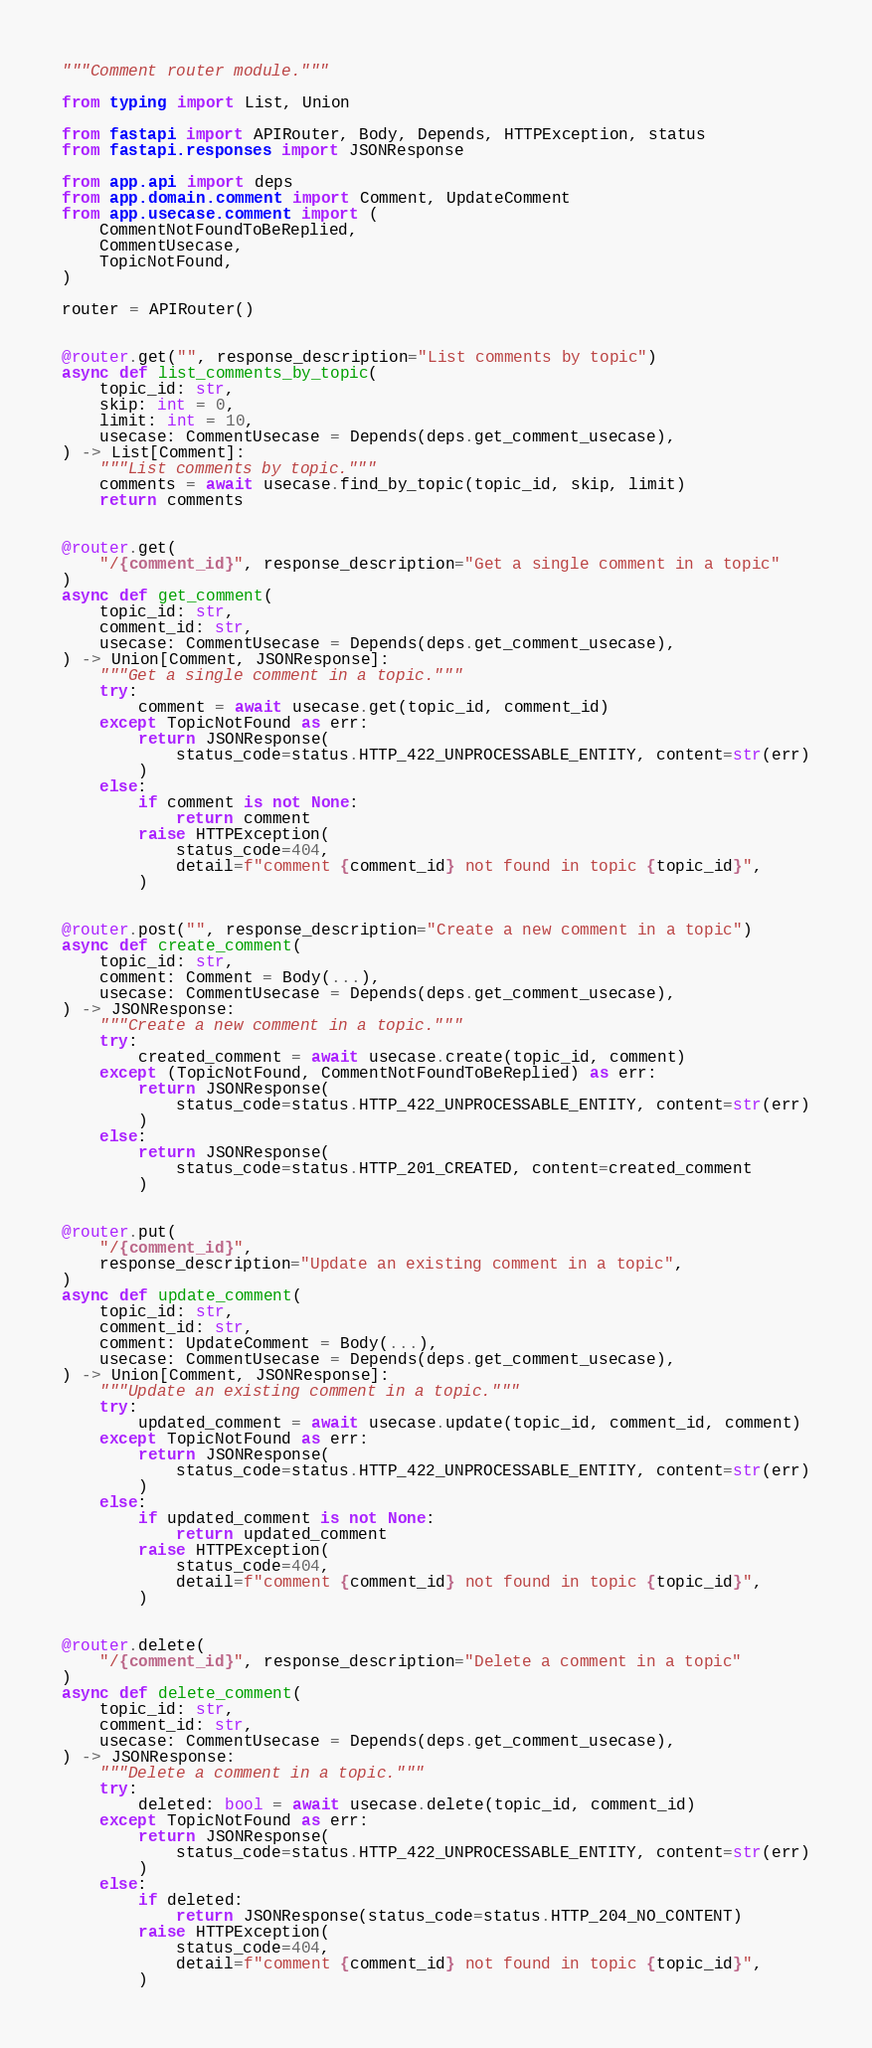<code> <loc_0><loc_0><loc_500><loc_500><_Python_>"""Comment router module."""

from typing import List, Union

from fastapi import APIRouter, Body, Depends, HTTPException, status
from fastapi.responses import JSONResponse

from app.api import deps
from app.domain.comment import Comment, UpdateComment
from app.usecase.comment import (
    CommentNotFoundToBeReplied,
    CommentUsecase,
    TopicNotFound,
)

router = APIRouter()


@router.get("", response_description="List comments by topic")
async def list_comments_by_topic(
    topic_id: str,
    skip: int = 0,
    limit: int = 10,
    usecase: CommentUsecase = Depends(deps.get_comment_usecase),
) -> List[Comment]:
    """List comments by topic."""
    comments = await usecase.find_by_topic(topic_id, skip, limit)
    return comments


@router.get(
    "/{comment_id}", response_description="Get a single comment in a topic"
)
async def get_comment(
    topic_id: str,
    comment_id: str,
    usecase: CommentUsecase = Depends(deps.get_comment_usecase),
) -> Union[Comment, JSONResponse]:
    """Get a single comment in a topic."""
    try:
        comment = await usecase.get(topic_id, comment_id)
    except TopicNotFound as err:
        return JSONResponse(
            status_code=status.HTTP_422_UNPROCESSABLE_ENTITY, content=str(err)
        )
    else:
        if comment is not None:
            return comment
        raise HTTPException(
            status_code=404,
            detail=f"comment {comment_id} not found in topic {topic_id}",
        )


@router.post("", response_description="Create a new comment in a topic")
async def create_comment(
    topic_id: str,
    comment: Comment = Body(...),
    usecase: CommentUsecase = Depends(deps.get_comment_usecase),
) -> JSONResponse:
    """Create a new comment in a topic."""
    try:
        created_comment = await usecase.create(topic_id, comment)
    except (TopicNotFound, CommentNotFoundToBeReplied) as err:
        return JSONResponse(
            status_code=status.HTTP_422_UNPROCESSABLE_ENTITY, content=str(err)
        )
    else:
        return JSONResponse(
            status_code=status.HTTP_201_CREATED, content=created_comment
        )


@router.put(
    "/{comment_id}",
    response_description="Update an existing comment in a topic",
)
async def update_comment(
    topic_id: str,
    comment_id: str,
    comment: UpdateComment = Body(...),
    usecase: CommentUsecase = Depends(deps.get_comment_usecase),
) -> Union[Comment, JSONResponse]:
    """Update an existing comment in a topic."""
    try:
        updated_comment = await usecase.update(topic_id, comment_id, comment)
    except TopicNotFound as err:
        return JSONResponse(
            status_code=status.HTTP_422_UNPROCESSABLE_ENTITY, content=str(err)
        )
    else:
        if updated_comment is not None:
            return updated_comment
        raise HTTPException(
            status_code=404,
            detail=f"comment {comment_id} not found in topic {topic_id}",
        )


@router.delete(
    "/{comment_id}", response_description="Delete a comment in a topic"
)
async def delete_comment(
    topic_id: str,
    comment_id: str,
    usecase: CommentUsecase = Depends(deps.get_comment_usecase),
) -> JSONResponse:
    """Delete a comment in a topic."""
    try:
        deleted: bool = await usecase.delete(topic_id, comment_id)
    except TopicNotFound as err:
        return JSONResponse(
            status_code=status.HTTP_422_UNPROCESSABLE_ENTITY, content=str(err)
        )
    else:
        if deleted:
            return JSONResponse(status_code=status.HTTP_204_NO_CONTENT)
        raise HTTPException(
            status_code=404,
            detail=f"comment {comment_id} not found in topic {topic_id}",
        )
</code> 